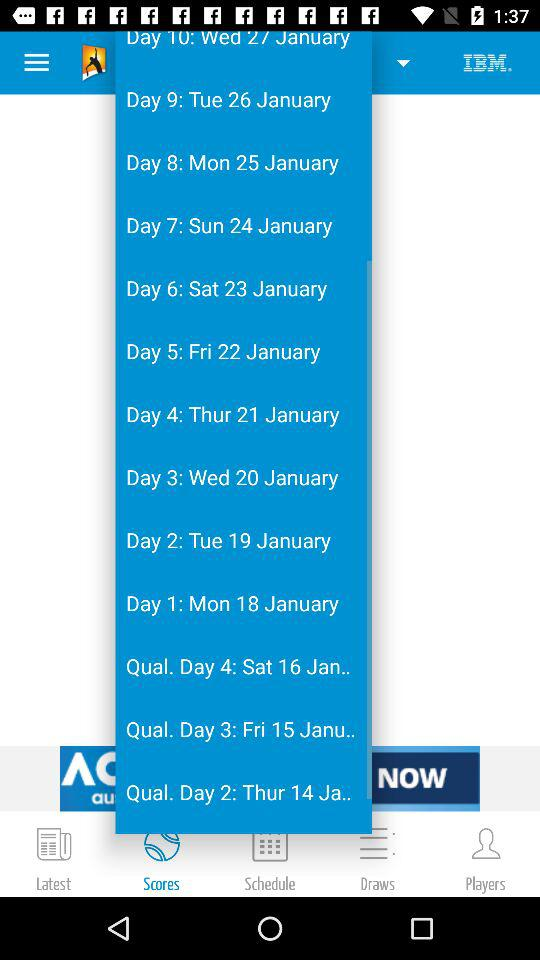What is the date on Qual. Day 3? The date is "Fri 15 Janu..". 